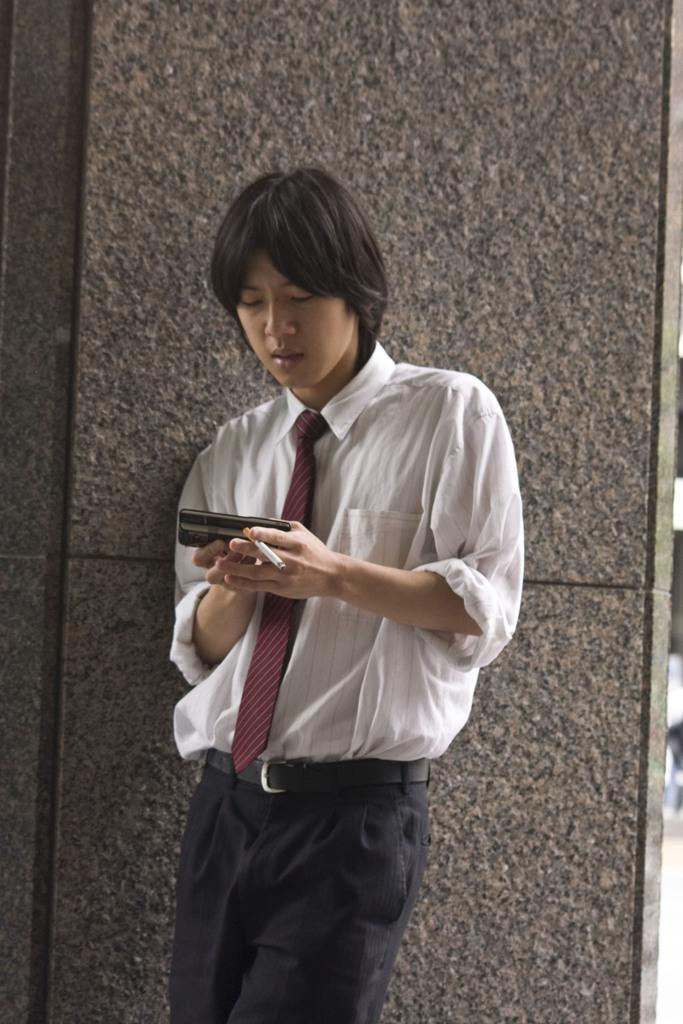What is the man in the image doing? The man is standing in the image and holding a mobile and a cigarette. Where is the man located in the image? The man is in the middle of the image. What can be seen in the background of the image? There is a wall in the background of the image. What type of current is flowing through the man's body in the image? There is no indication of any current flowing through the man's body in the image. Can you tell me how the man is interacting with space in the image? The image does not depict the man interacting with space; it is a regular image of a man standing with a mobile and a cigarette. 